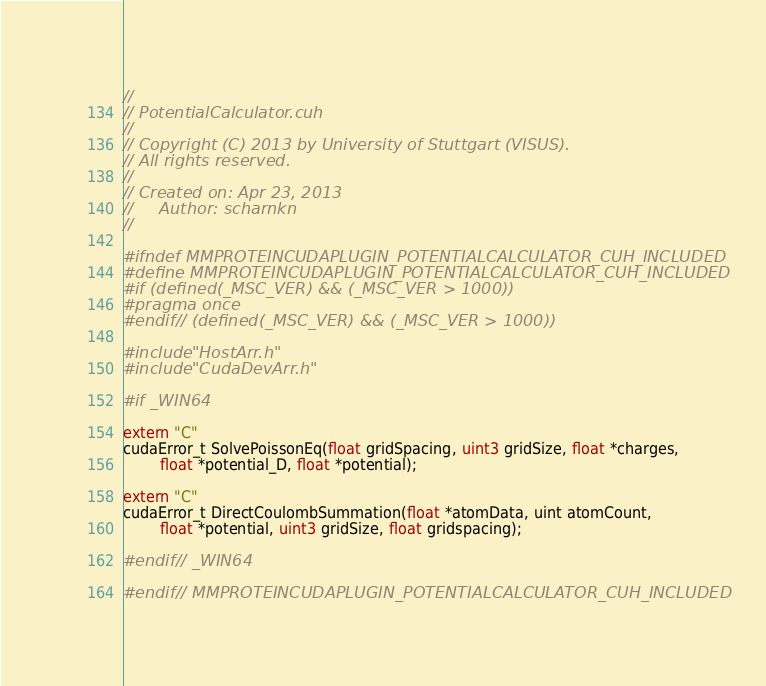Convert code to text. <code><loc_0><loc_0><loc_500><loc_500><_Cuda_>//
// PotentialCalculator.cuh
//
// Copyright (C) 2013 by University of Stuttgart (VISUS).
// All rights reserved.
//
// Created on: Apr 23, 2013
//     Author: scharnkn
//

#ifndef MMPROTEINCUDAPLUGIN_POTENTIALCALCULATOR_CUH_INCLUDED
#define MMPROTEINCUDAPLUGIN_POTENTIALCALCULATOR_CUH_INCLUDED
#if (defined(_MSC_VER) && (_MSC_VER > 1000))
#pragma once
#endif // (defined(_MSC_VER) && (_MSC_VER > 1000))

#include "HostArr.h"
#include "CudaDevArr.h"

#if _WIN64

extern "C"
cudaError_t SolvePoissonEq(float gridSpacing, uint3 gridSize, float *charges,
        float *potential_D, float *potential);

extern "C"
cudaError_t DirectCoulombSummation(float *atomData, uint atomCount,
        float *potential, uint3 gridSize, float gridspacing);

#endif // _WIN64

#endif // MMPROTEINCUDAPLUGIN_POTENTIALCALCULATOR_CUH_INCLUDED
</code> 